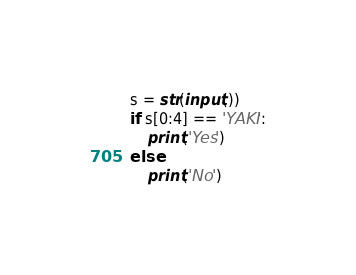<code> <loc_0><loc_0><loc_500><loc_500><_Python_>s = str(input())
if s[0:4] == 'YAKI':
    print('Yes')
else:
    print('No')</code> 